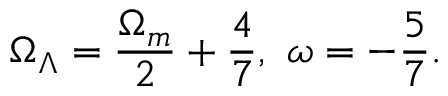Convert formula to latex. <formula><loc_0><loc_0><loc_500><loc_500>\Omega _ { \Lambda } = \frac { \Omega _ { m } } { 2 } + \frac { 4 } { 7 } , \ \omega = - \frac { 5 } { 7 } .</formula> 